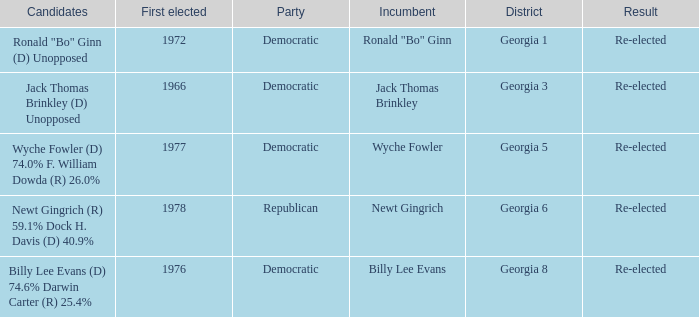How many parties backed candidates newt gingrich (r) 5 1.0. 